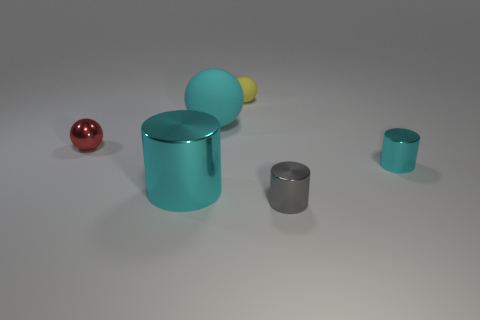What number of metal things are big cylinders or cyan cylinders?
Give a very brief answer. 2. What is the shape of the big metal object that is the same color as the large matte thing?
Ensure brevity in your answer.  Cylinder. What number of cyan metallic cylinders have the same size as the yellow rubber object?
Offer a very short reply. 1. What color is the ball that is in front of the yellow sphere and right of the metal ball?
Provide a short and direct response. Cyan. What number of things are tiny matte balls or red metallic objects?
Your response must be concise. 2. What number of small things are either gray spheres or gray metallic objects?
Your answer should be compact. 1. Is there anything else of the same color as the large ball?
Offer a very short reply. Yes. There is a metal object that is on the left side of the gray shiny cylinder and right of the small red thing; what size is it?
Ensure brevity in your answer.  Large. There is a sphere that is in front of the big matte sphere; does it have the same color as the metallic cylinder that is to the left of the large matte sphere?
Provide a succinct answer. No. How many other objects are there of the same material as the big ball?
Offer a very short reply. 1. 